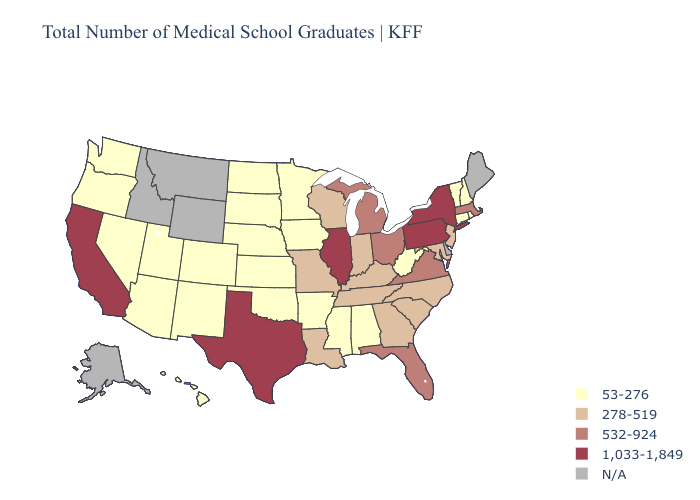Which states have the highest value in the USA?
Keep it brief. California, Illinois, New York, Pennsylvania, Texas. Among the states that border Virginia , which have the highest value?
Concise answer only. Kentucky, Maryland, North Carolina, Tennessee. What is the highest value in states that border Colorado?
Write a very short answer. 53-276. Name the states that have a value in the range 532-924?
Answer briefly. Florida, Massachusetts, Michigan, Ohio, Virginia. Name the states that have a value in the range 532-924?
Answer briefly. Florida, Massachusetts, Michigan, Ohio, Virginia. What is the lowest value in states that border Arkansas?
Answer briefly. 53-276. Does Pennsylvania have the highest value in the Northeast?
Give a very brief answer. Yes. Is the legend a continuous bar?
Short answer required. No. Among the states that border Alabama , does Georgia have the lowest value?
Quick response, please. No. What is the highest value in states that border Washington?
Answer briefly. 53-276. Name the states that have a value in the range N/A?
Be succinct. Alaska, Delaware, Idaho, Maine, Montana, Wyoming. What is the lowest value in the MidWest?
Write a very short answer. 53-276. Does West Virginia have the lowest value in the South?
Quick response, please. Yes. 